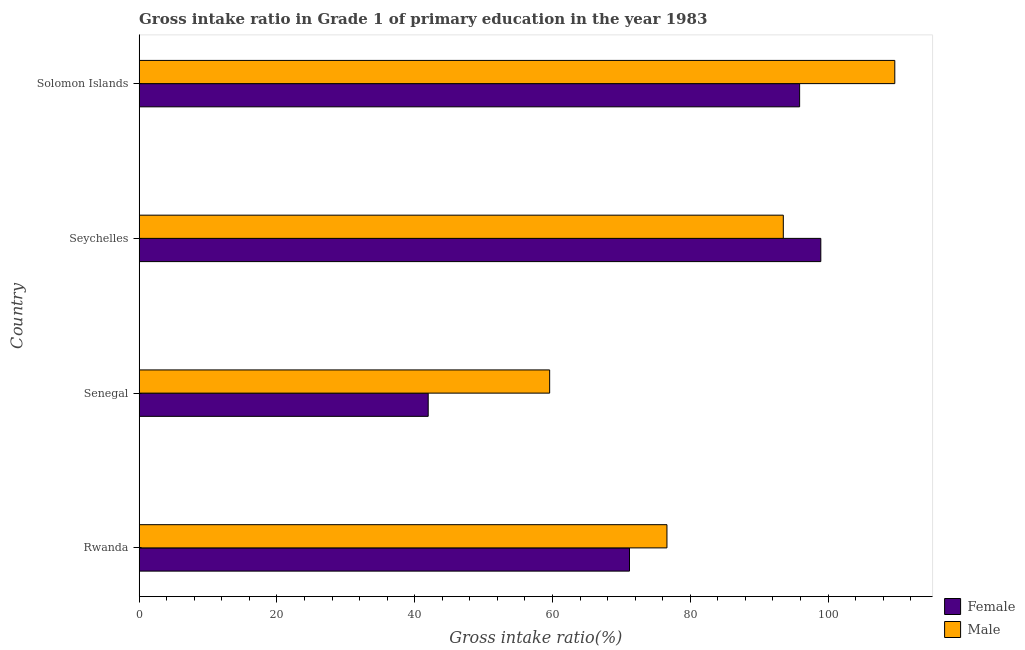Are the number of bars per tick equal to the number of legend labels?
Ensure brevity in your answer.  Yes. How many bars are there on the 4th tick from the bottom?
Give a very brief answer. 2. What is the label of the 3rd group of bars from the top?
Provide a short and direct response. Senegal. What is the gross intake ratio(male) in Seychelles?
Your answer should be compact. 93.51. Across all countries, what is the maximum gross intake ratio(male)?
Your response must be concise. 109.7. Across all countries, what is the minimum gross intake ratio(male)?
Offer a terse response. 59.59. In which country was the gross intake ratio(female) maximum?
Ensure brevity in your answer.  Seychelles. In which country was the gross intake ratio(female) minimum?
Provide a succinct answer. Senegal. What is the total gross intake ratio(male) in the graph?
Offer a very short reply. 339.43. What is the difference between the gross intake ratio(female) in Senegal and that in Solomon Islands?
Your answer should be compact. -53.92. What is the difference between the gross intake ratio(male) in Solomon Islands and the gross intake ratio(female) in Rwanda?
Your answer should be compact. 38.51. What is the average gross intake ratio(male) per country?
Your response must be concise. 84.86. What is the difference between the gross intake ratio(male) and gross intake ratio(female) in Solomon Islands?
Provide a succinct answer. 13.82. What is the ratio of the gross intake ratio(female) in Rwanda to that in Solomon Islands?
Offer a very short reply. 0.74. Is the difference between the gross intake ratio(female) in Rwanda and Seychelles greater than the difference between the gross intake ratio(male) in Rwanda and Seychelles?
Your response must be concise. No. What is the difference between the highest and the second highest gross intake ratio(female)?
Offer a very short reply. 3.07. What does the 2nd bar from the top in Rwanda represents?
Provide a succinct answer. Female. Are all the bars in the graph horizontal?
Your answer should be very brief. Yes. How many countries are there in the graph?
Your answer should be very brief. 4. What is the difference between two consecutive major ticks on the X-axis?
Offer a very short reply. 20. Does the graph contain grids?
Your answer should be very brief. No. Where does the legend appear in the graph?
Your response must be concise. Bottom right. What is the title of the graph?
Offer a very short reply. Gross intake ratio in Grade 1 of primary education in the year 1983. What is the label or title of the X-axis?
Provide a short and direct response. Gross intake ratio(%). What is the label or title of the Y-axis?
Offer a very short reply. Country. What is the Gross intake ratio(%) in Female in Rwanda?
Your response must be concise. 71.18. What is the Gross intake ratio(%) of Male in Rwanda?
Ensure brevity in your answer.  76.62. What is the Gross intake ratio(%) of Female in Senegal?
Provide a succinct answer. 41.96. What is the Gross intake ratio(%) of Male in Senegal?
Give a very brief answer. 59.59. What is the Gross intake ratio(%) of Female in Seychelles?
Offer a very short reply. 98.96. What is the Gross intake ratio(%) in Male in Seychelles?
Your answer should be very brief. 93.51. What is the Gross intake ratio(%) in Female in Solomon Islands?
Offer a very short reply. 95.88. What is the Gross intake ratio(%) in Male in Solomon Islands?
Your response must be concise. 109.7. Across all countries, what is the maximum Gross intake ratio(%) in Female?
Provide a short and direct response. 98.96. Across all countries, what is the maximum Gross intake ratio(%) of Male?
Offer a terse response. 109.7. Across all countries, what is the minimum Gross intake ratio(%) of Female?
Offer a very short reply. 41.96. Across all countries, what is the minimum Gross intake ratio(%) of Male?
Ensure brevity in your answer.  59.59. What is the total Gross intake ratio(%) of Female in the graph?
Provide a short and direct response. 307.99. What is the total Gross intake ratio(%) of Male in the graph?
Ensure brevity in your answer.  339.43. What is the difference between the Gross intake ratio(%) in Female in Rwanda and that in Senegal?
Offer a very short reply. 29.22. What is the difference between the Gross intake ratio(%) of Male in Rwanda and that in Senegal?
Offer a terse response. 17.03. What is the difference between the Gross intake ratio(%) in Female in Rwanda and that in Seychelles?
Give a very brief answer. -27.77. What is the difference between the Gross intake ratio(%) in Male in Rwanda and that in Seychelles?
Give a very brief answer. -16.89. What is the difference between the Gross intake ratio(%) of Female in Rwanda and that in Solomon Islands?
Your response must be concise. -24.7. What is the difference between the Gross intake ratio(%) in Male in Rwanda and that in Solomon Islands?
Make the answer very short. -33.08. What is the difference between the Gross intake ratio(%) of Female in Senegal and that in Seychelles?
Offer a very short reply. -57. What is the difference between the Gross intake ratio(%) in Male in Senegal and that in Seychelles?
Provide a succinct answer. -33.92. What is the difference between the Gross intake ratio(%) in Female in Senegal and that in Solomon Islands?
Your response must be concise. -53.92. What is the difference between the Gross intake ratio(%) in Male in Senegal and that in Solomon Islands?
Ensure brevity in your answer.  -50.11. What is the difference between the Gross intake ratio(%) of Female in Seychelles and that in Solomon Islands?
Keep it short and to the point. 3.07. What is the difference between the Gross intake ratio(%) of Male in Seychelles and that in Solomon Islands?
Your response must be concise. -16.19. What is the difference between the Gross intake ratio(%) of Female in Rwanda and the Gross intake ratio(%) of Male in Senegal?
Provide a short and direct response. 11.59. What is the difference between the Gross intake ratio(%) in Female in Rwanda and the Gross intake ratio(%) in Male in Seychelles?
Provide a short and direct response. -22.33. What is the difference between the Gross intake ratio(%) of Female in Rwanda and the Gross intake ratio(%) of Male in Solomon Islands?
Your response must be concise. -38.51. What is the difference between the Gross intake ratio(%) of Female in Senegal and the Gross intake ratio(%) of Male in Seychelles?
Offer a very short reply. -51.55. What is the difference between the Gross intake ratio(%) of Female in Senegal and the Gross intake ratio(%) of Male in Solomon Islands?
Your answer should be very brief. -67.74. What is the difference between the Gross intake ratio(%) of Female in Seychelles and the Gross intake ratio(%) of Male in Solomon Islands?
Provide a succinct answer. -10.74. What is the average Gross intake ratio(%) of Female per country?
Provide a short and direct response. 77. What is the average Gross intake ratio(%) of Male per country?
Make the answer very short. 84.86. What is the difference between the Gross intake ratio(%) of Female and Gross intake ratio(%) of Male in Rwanda?
Your answer should be very brief. -5.44. What is the difference between the Gross intake ratio(%) of Female and Gross intake ratio(%) of Male in Senegal?
Keep it short and to the point. -17.63. What is the difference between the Gross intake ratio(%) in Female and Gross intake ratio(%) in Male in Seychelles?
Give a very brief answer. 5.44. What is the difference between the Gross intake ratio(%) of Female and Gross intake ratio(%) of Male in Solomon Islands?
Ensure brevity in your answer.  -13.82. What is the ratio of the Gross intake ratio(%) in Female in Rwanda to that in Senegal?
Keep it short and to the point. 1.7. What is the ratio of the Gross intake ratio(%) of Male in Rwanda to that in Senegal?
Ensure brevity in your answer.  1.29. What is the ratio of the Gross intake ratio(%) of Female in Rwanda to that in Seychelles?
Make the answer very short. 0.72. What is the ratio of the Gross intake ratio(%) of Male in Rwanda to that in Seychelles?
Offer a terse response. 0.82. What is the ratio of the Gross intake ratio(%) in Female in Rwanda to that in Solomon Islands?
Provide a succinct answer. 0.74. What is the ratio of the Gross intake ratio(%) in Male in Rwanda to that in Solomon Islands?
Provide a short and direct response. 0.7. What is the ratio of the Gross intake ratio(%) of Female in Senegal to that in Seychelles?
Your response must be concise. 0.42. What is the ratio of the Gross intake ratio(%) of Male in Senegal to that in Seychelles?
Give a very brief answer. 0.64. What is the ratio of the Gross intake ratio(%) in Female in Senegal to that in Solomon Islands?
Give a very brief answer. 0.44. What is the ratio of the Gross intake ratio(%) of Male in Senegal to that in Solomon Islands?
Ensure brevity in your answer.  0.54. What is the ratio of the Gross intake ratio(%) of Female in Seychelles to that in Solomon Islands?
Provide a succinct answer. 1.03. What is the ratio of the Gross intake ratio(%) in Male in Seychelles to that in Solomon Islands?
Offer a very short reply. 0.85. What is the difference between the highest and the second highest Gross intake ratio(%) of Female?
Your answer should be very brief. 3.07. What is the difference between the highest and the second highest Gross intake ratio(%) in Male?
Your response must be concise. 16.19. What is the difference between the highest and the lowest Gross intake ratio(%) of Female?
Your answer should be compact. 57. What is the difference between the highest and the lowest Gross intake ratio(%) of Male?
Your answer should be compact. 50.11. 